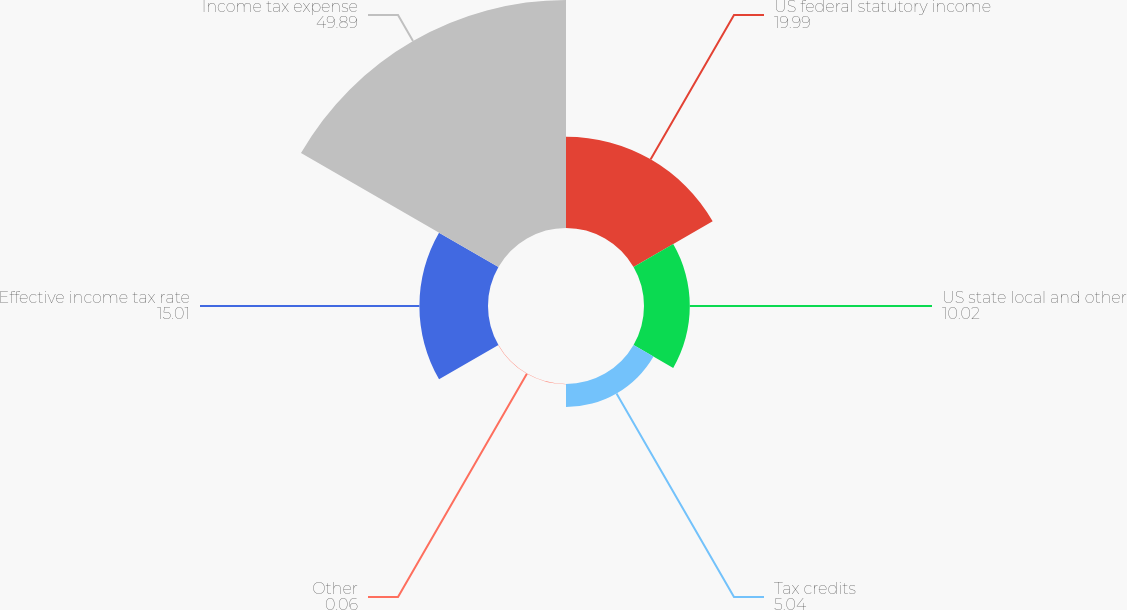<chart> <loc_0><loc_0><loc_500><loc_500><pie_chart><fcel>US federal statutory income<fcel>US state local and other<fcel>Tax credits<fcel>Other<fcel>Effective income tax rate<fcel>Income tax expense<nl><fcel>19.99%<fcel>10.02%<fcel>5.04%<fcel>0.06%<fcel>15.01%<fcel>49.89%<nl></chart> 